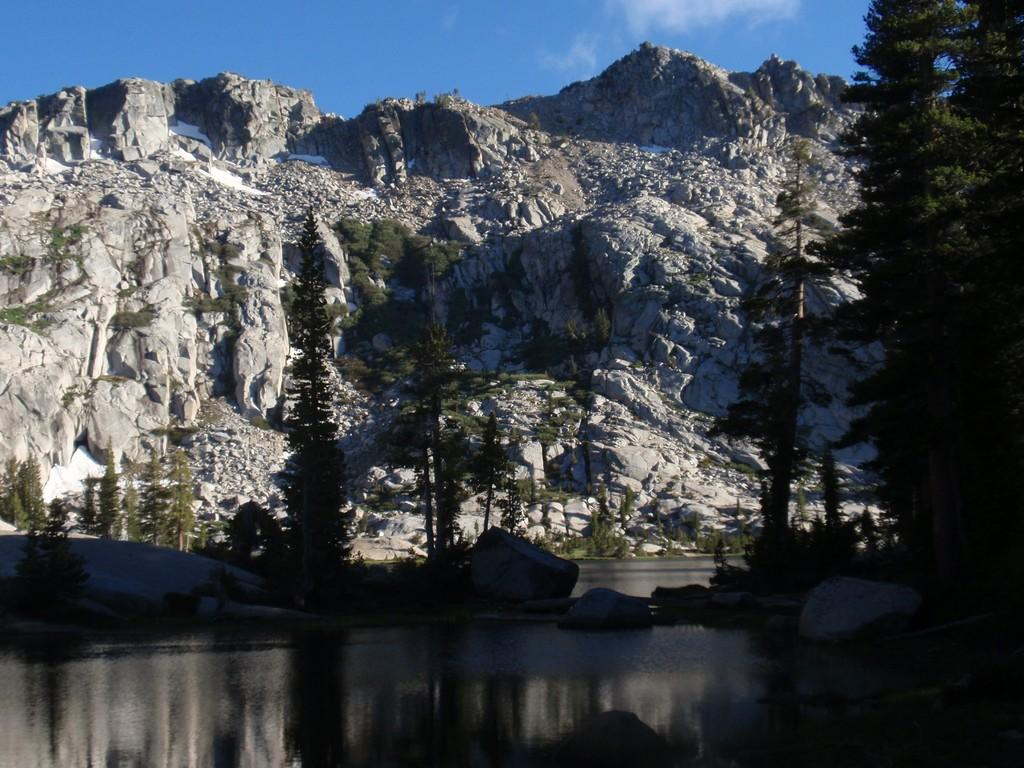What type of natural landform can be seen in the image? There are mountains in the image. What else can be seen in the image besides the mountains? There is water and trees visible in the image. What is the color of the sky in the image? The sky is blue in color. Can you see a seat in the image? There is no seat present in the image. What type of error can be seen in the image? There is no error present in the image. 